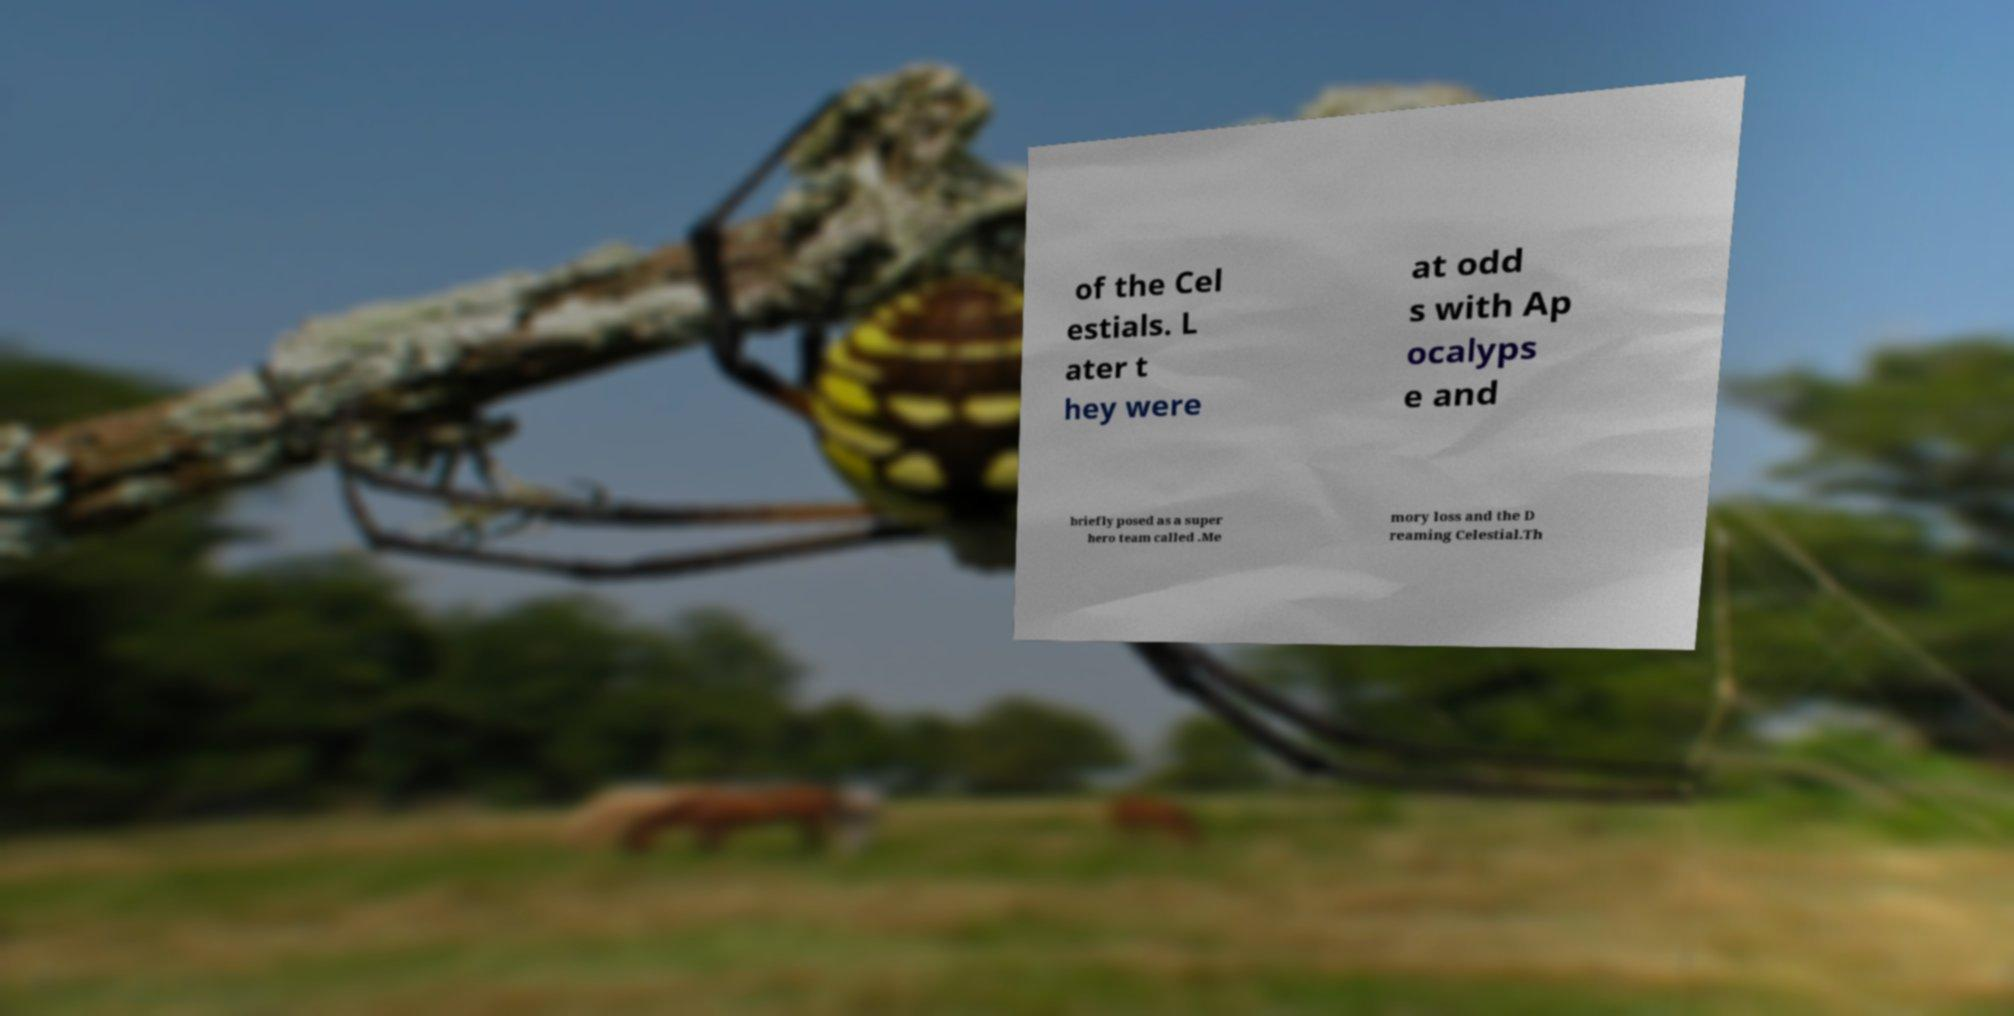Could you extract and type out the text from this image? of the Cel estials. L ater t hey were at odd s with Ap ocalyps e and briefly posed as a super hero team called .Me mory loss and the D reaming Celestial.Th 